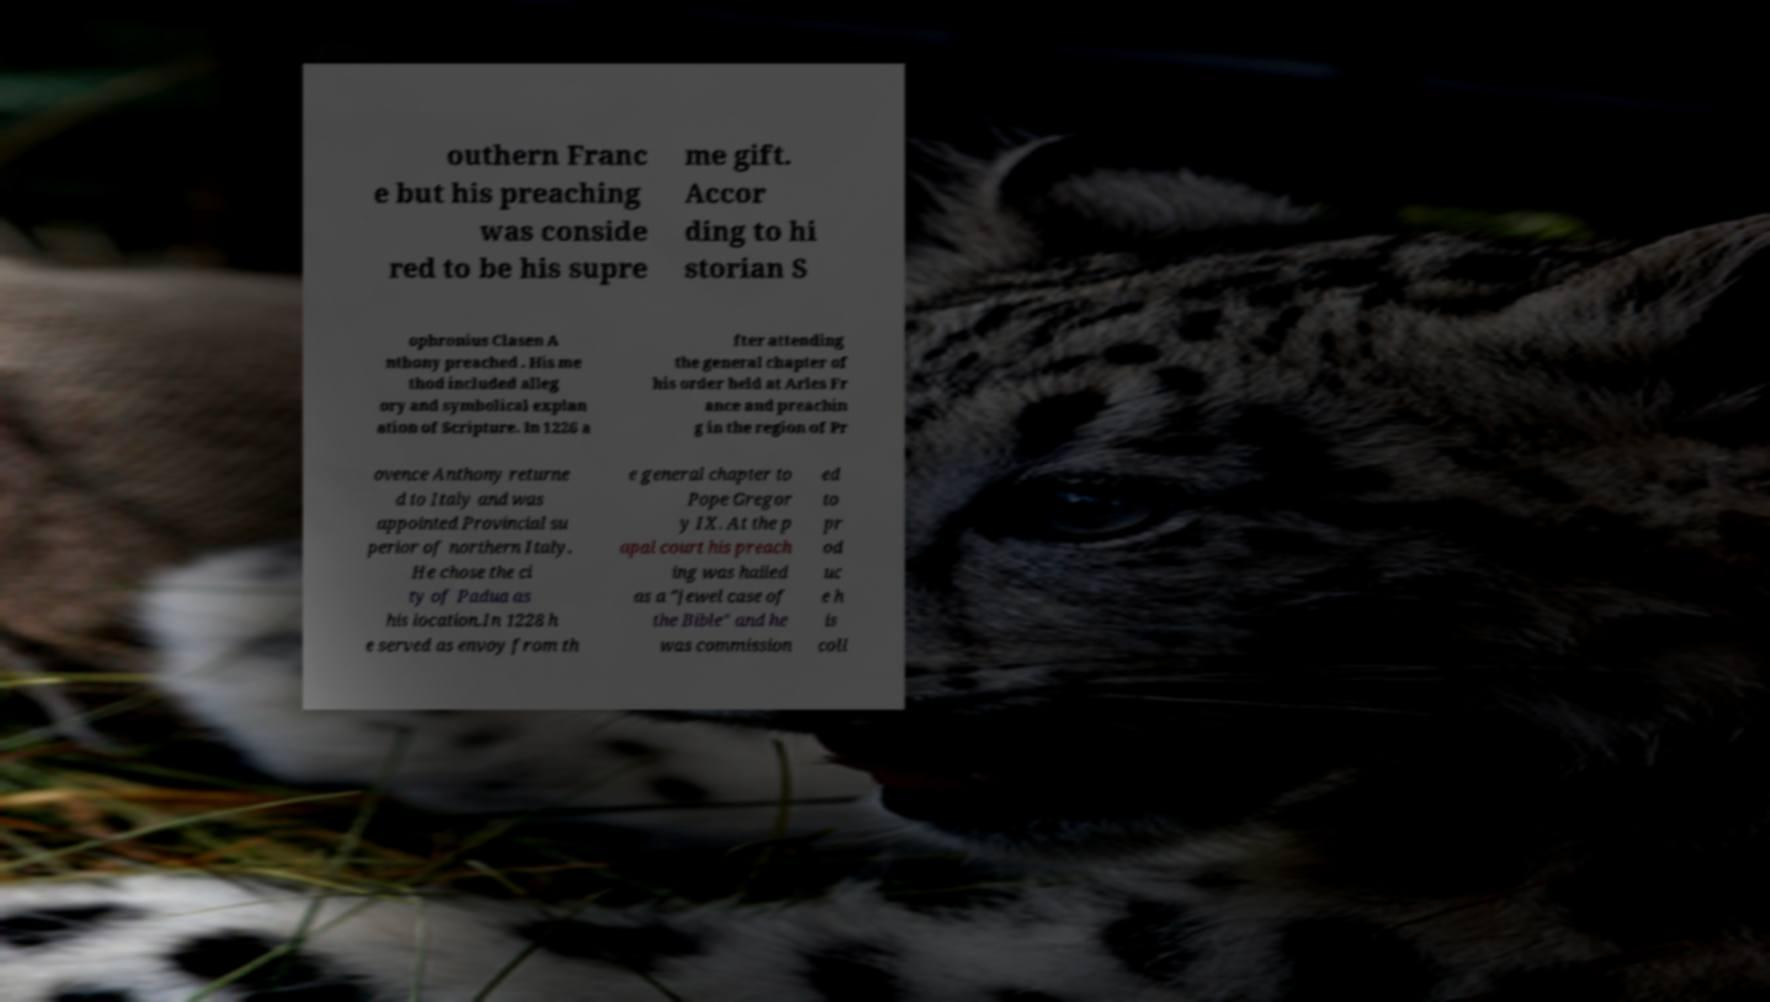What messages or text are displayed in this image? I need them in a readable, typed format. outhern Franc e but his preaching was conside red to be his supre me gift. Accor ding to hi storian S ophronius Clasen A nthony preached . His me thod included alleg ory and symbolical explan ation of Scripture. In 1226 a fter attending the general chapter of his order held at Arles Fr ance and preachin g in the region of Pr ovence Anthony returne d to Italy and was appointed Provincial su perior of northern Italy. He chose the ci ty of Padua as his location.In 1228 h e served as envoy from th e general chapter to Pope Gregor y IX. At the p apal court his preach ing was hailed as a "jewel case of the Bible" and he was commission ed to pr od uc e h is coll 